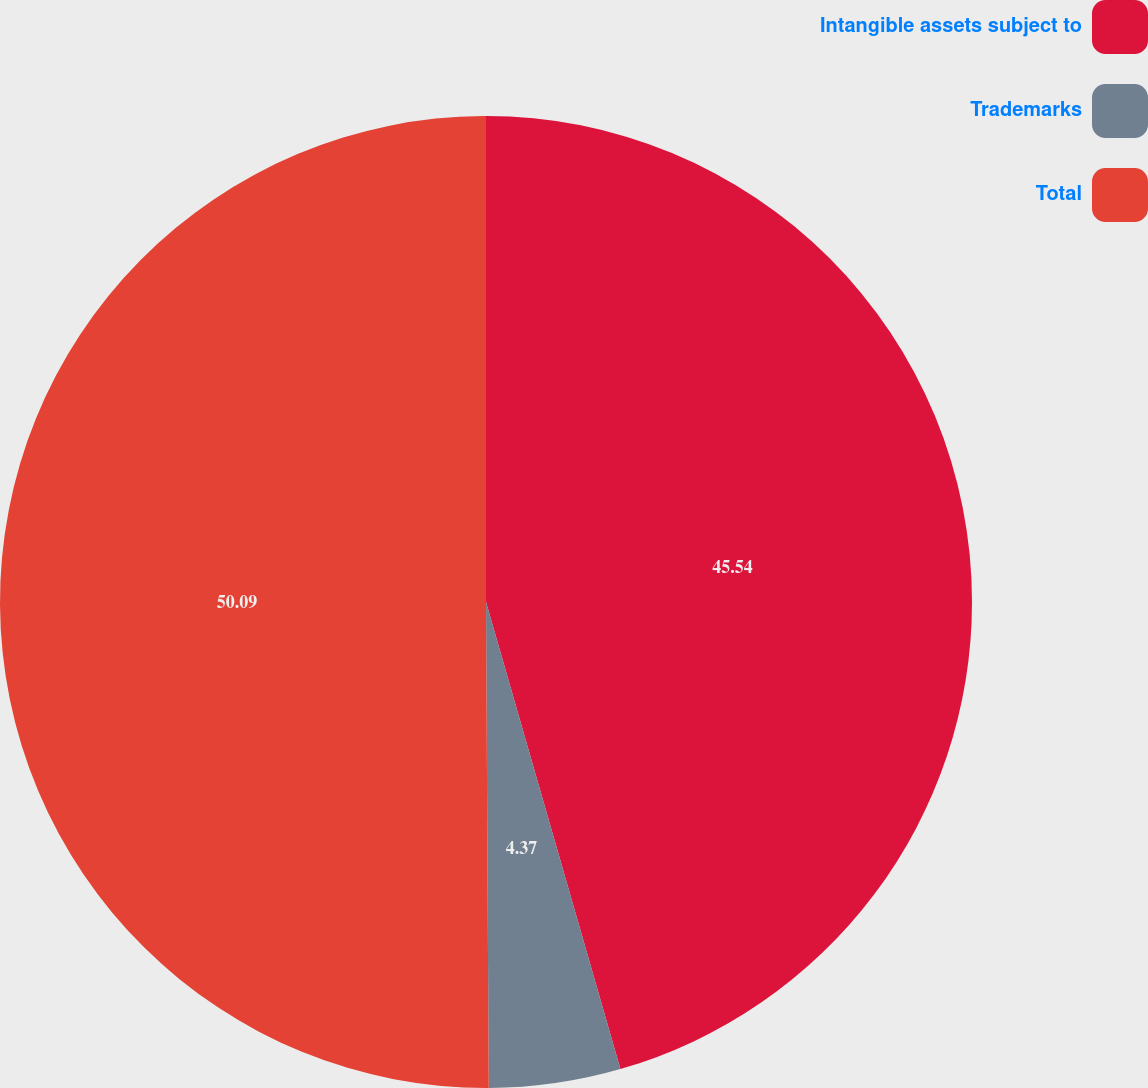Convert chart to OTSL. <chart><loc_0><loc_0><loc_500><loc_500><pie_chart><fcel>Intangible assets subject to<fcel>Trademarks<fcel>Total<nl><fcel>45.54%<fcel>4.37%<fcel>50.09%<nl></chart> 